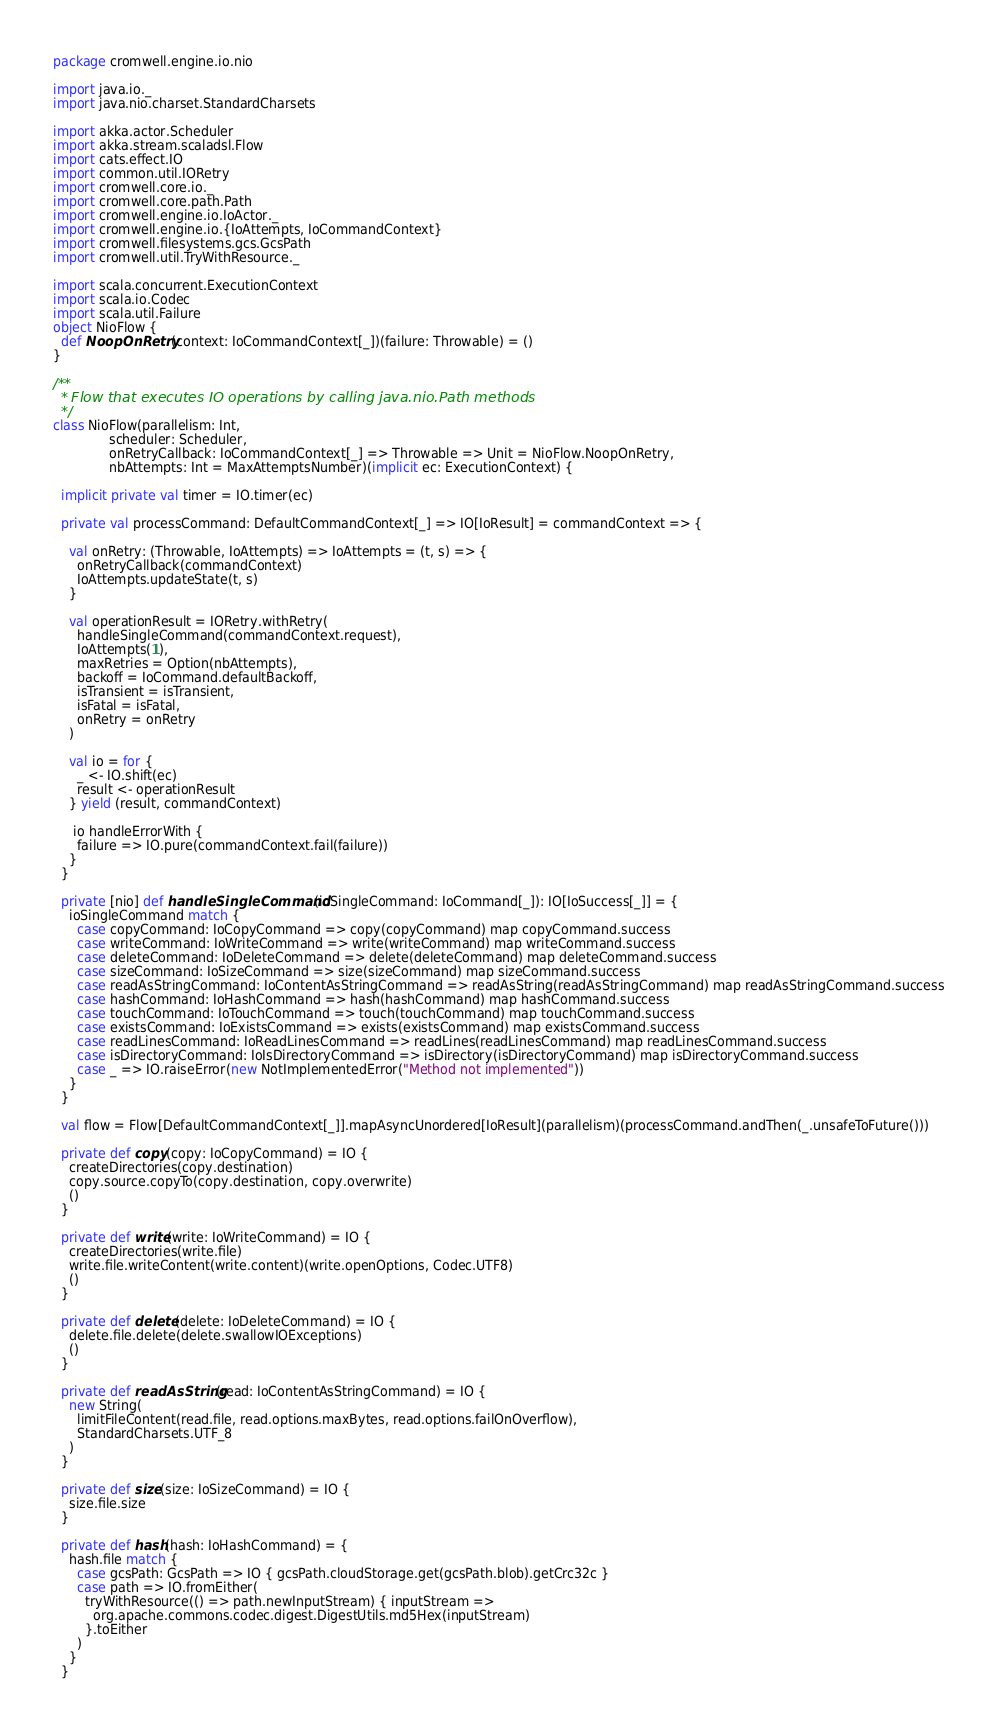Convert code to text. <code><loc_0><loc_0><loc_500><loc_500><_Scala_>package cromwell.engine.io.nio

import java.io._
import java.nio.charset.StandardCharsets

import akka.actor.Scheduler
import akka.stream.scaladsl.Flow
import cats.effect.IO
import common.util.IORetry
import cromwell.core.io._
import cromwell.core.path.Path
import cromwell.engine.io.IoActor._
import cromwell.engine.io.{IoAttempts, IoCommandContext}
import cromwell.filesystems.gcs.GcsPath
import cromwell.util.TryWithResource._

import scala.concurrent.ExecutionContext
import scala.io.Codec
import scala.util.Failure
object NioFlow {
  def NoopOnRetry(context: IoCommandContext[_])(failure: Throwable) = ()
}

/**
  * Flow that executes IO operations by calling java.nio.Path methods
  */
class NioFlow(parallelism: Int,
              scheduler: Scheduler,
              onRetryCallback: IoCommandContext[_] => Throwable => Unit = NioFlow.NoopOnRetry,
              nbAttempts: Int = MaxAttemptsNumber)(implicit ec: ExecutionContext) {
  
  implicit private val timer = IO.timer(ec)
  
  private val processCommand: DefaultCommandContext[_] => IO[IoResult] = commandContext => {

    val onRetry: (Throwable, IoAttempts) => IoAttempts = (t, s) => {
      onRetryCallback(commandContext)
      IoAttempts.updateState(t, s)
    }

    val operationResult = IORetry.withRetry(
      handleSingleCommand(commandContext.request),
      IoAttempts(1),
      maxRetries = Option(nbAttempts),
      backoff = IoCommand.defaultBackoff,
      isTransient = isTransient,
      isFatal = isFatal,
      onRetry = onRetry
    )

    val io = for {
      _ <- IO.shift(ec)
      result <- operationResult
    } yield (result, commandContext)
    
     io handleErrorWith {
      failure => IO.pure(commandContext.fail(failure))
    }
  }

  private [nio] def handleSingleCommand(ioSingleCommand: IoCommand[_]): IO[IoSuccess[_]] = {
    ioSingleCommand match {
      case copyCommand: IoCopyCommand => copy(copyCommand) map copyCommand.success
      case writeCommand: IoWriteCommand => write(writeCommand) map writeCommand.success
      case deleteCommand: IoDeleteCommand => delete(deleteCommand) map deleteCommand.success
      case sizeCommand: IoSizeCommand => size(sizeCommand) map sizeCommand.success
      case readAsStringCommand: IoContentAsStringCommand => readAsString(readAsStringCommand) map readAsStringCommand.success
      case hashCommand: IoHashCommand => hash(hashCommand) map hashCommand.success
      case touchCommand: IoTouchCommand => touch(touchCommand) map touchCommand.success
      case existsCommand: IoExistsCommand => exists(existsCommand) map existsCommand.success
      case readLinesCommand: IoReadLinesCommand => readLines(readLinesCommand) map readLinesCommand.success
      case isDirectoryCommand: IoIsDirectoryCommand => isDirectory(isDirectoryCommand) map isDirectoryCommand.success
      case _ => IO.raiseError(new NotImplementedError("Method not implemented"))
    }
  }

  val flow = Flow[DefaultCommandContext[_]].mapAsyncUnordered[IoResult](parallelism)(processCommand.andThen(_.unsafeToFuture()))

  private def copy(copy: IoCopyCommand) = IO {
    createDirectories(copy.destination)
    copy.source.copyTo(copy.destination, copy.overwrite)
    ()
  }

  private def write(write: IoWriteCommand) = IO {
    createDirectories(write.file)
    write.file.writeContent(write.content)(write.openOptions, Codec.UTF8)
    ()
  }

  private def delete(delete: IoDeleteCommand) = IO {
    delete.file.delete(delete.swallowIOExceptions)
    ()
  }

  private def readAsString(read: IoContentAsStringCommand) = IO {
    new String(
      limitFileContent(read.file, read.options.maxBytes, read.options.failOnOverflow),
      StandardCharsets.UTF_8
    )
  }

  private def size(size: IoSizeCommand) = IO {
    size.file.size
  }

  private def hash(hash: IoHashCommand) = {
    hash.file match {
      case gcsPath: GcsPath => IO { gcsPath.cloudStorage.get(gcsPath.blob).getCrc32c }
      case path => IO.fromEither(
        tryWithResource(() => path.newInputStream) { inputStream =>
          org.apache.commons.codec.digest.DigestUtils.md5Hex(inputStream)
        }.toEither
      )
    }
  }
</code> 